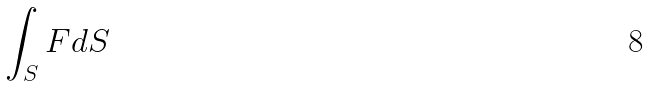Convert formula to latex. <formula><loc_0><loc_0><loc_500><loc_500>\int _ { S } F d S</formula> 